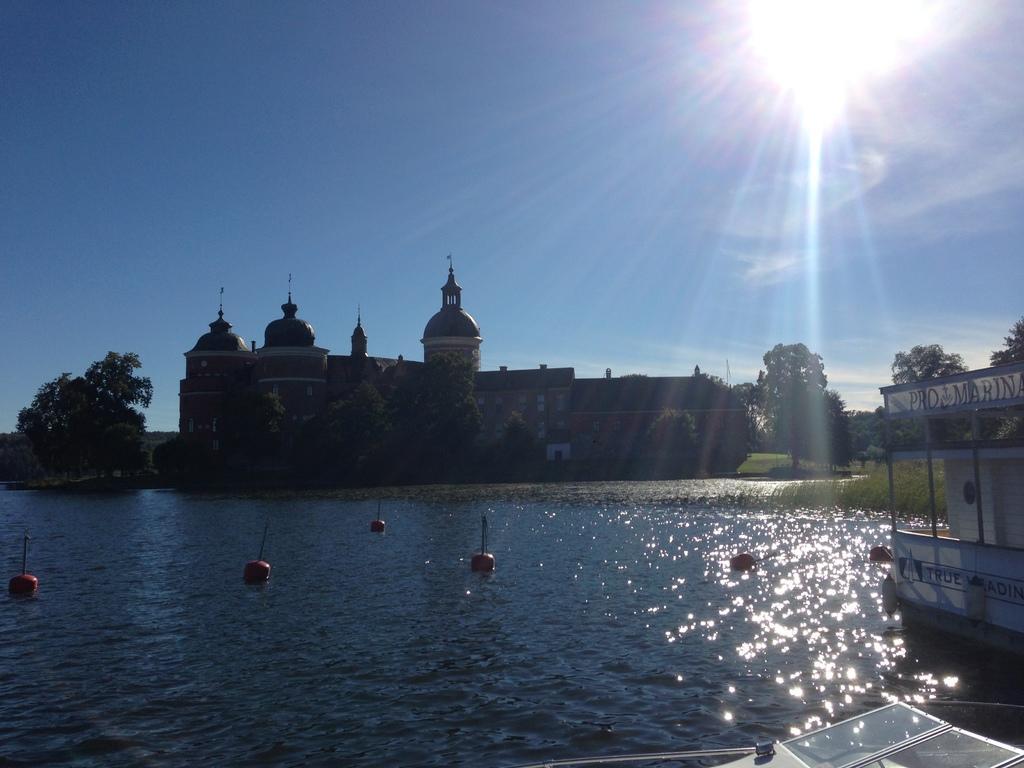Could you give a brief overview of what you see in this image? In this image I can see building, trees,grass,water, and in the bottom right corner it looks like a boat. And at the bottom of the image there is some object. Also in the background there is sky and sun. 